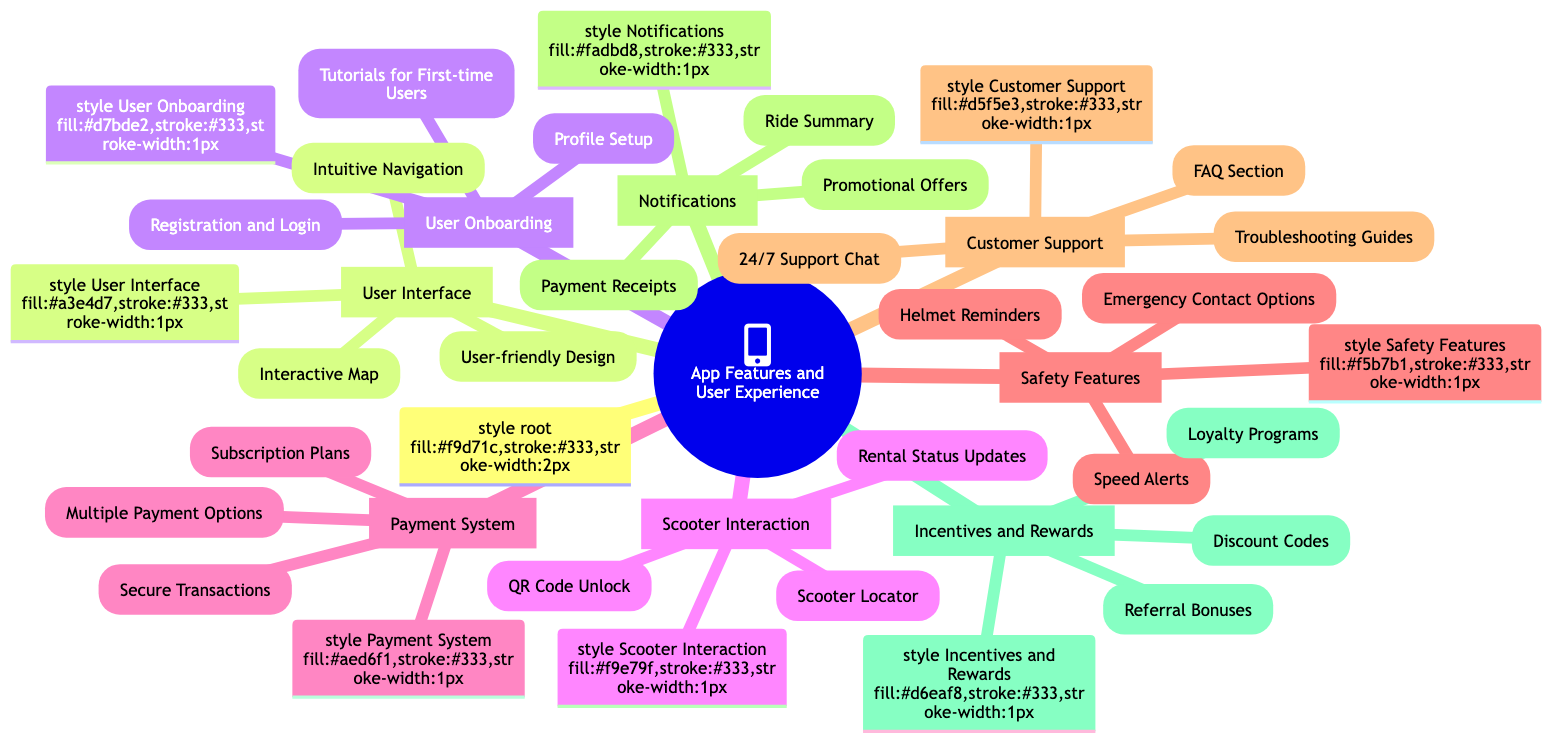What are the elements under User Interface? The elements under User Interface are listed as Intuitive Navigation, Interactive Map, and User-friendly Design, which can be found in the diagram.
Answer: Intuitive Navigation, Interactive Map, User-friendly Design How many main categories are in the mind map? The mind map contains eight main categories: User Interface, User Onboarding, Scooter Interaction, Payment System, Safety Features, Customer Support, Notifications, and Incentives and Rewards.
Answer: 8 What feature is common in both User Onboarding and Customer Support? Both categories, User Onboarding and Customer Support, include elements that focus on guiding users: Tutorials for First-time Users in User Onboarding and FAQ Section in Customer Support.
Answer: Guidance Which category includes Secure Transactions? The category that includes Secure Transactions is Payment System, as indicated in the mind map.
Answer: Payment System What is the relationship between Notifications and Incentives and Rewards? Notifications and Incentives and Rewards are both separate categories in the mind map that provide added value to the user experience through different means: Notifications through ride summaries and promotional offers, and Incentives and Rewards through bonuses and discount codes.
Answer: Separate but complementary How many elements are listed under Scooter Interaction? The Scooter Interaction category lists three elements: Scooter Locator, QR Code Unlock, and Rental Status Updates, making for a total of three elements.
Answer: 3 What feature aims to enhance safety while riding? The features in the Safety Features category focus on enhancing safety while riding, including Helmet Reminders, Speed Alerts, and Emergency Contact Options.
Answer: Helmet Reminders What type of support is available according to the mind map? The mind map mentions 24/7 Support Chat under the Customer Support category as the type of support available for users.
Answer: 24/7 Support Chat What incentive is provided for user referrals? The incentives offered for user referrals include Referral Bonuses, which is explicitly noted in the Incentives and Rewards category of the mind map.
Answer: Referral Bonuses 